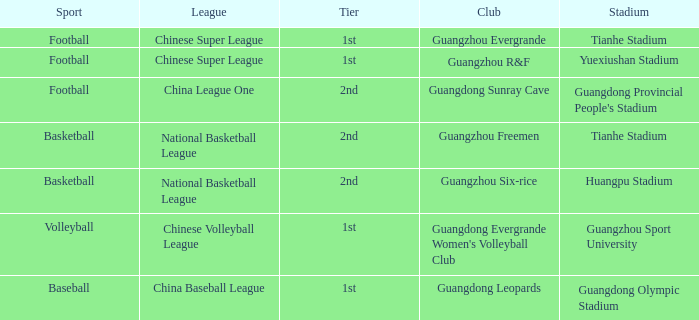Which echelon is for football at tianhe stadium? 1st. 